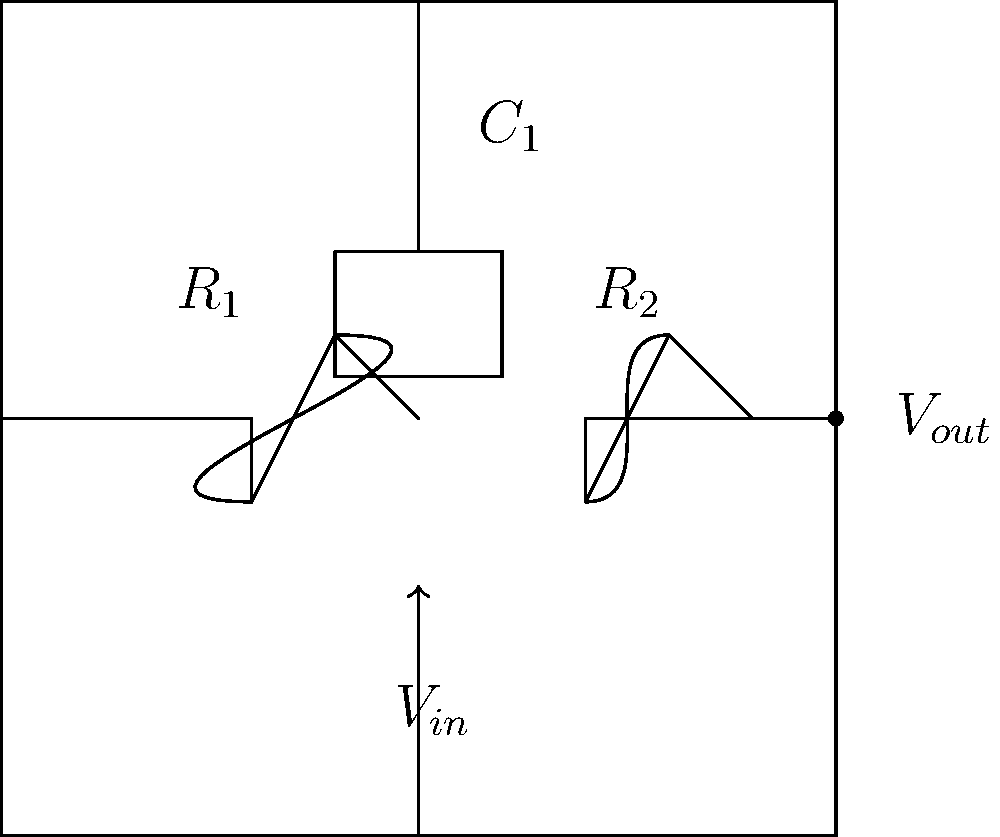In the given circuit schematic, which component determines the high-frequency response of the circuit, and how would increasing its value affect the circuit's behavior? To answer this question, let's analyze the circuit step-by-step:

1. The circuit shown is a basic RC low-pass filter.

2. It consists of two resistors ($R_1$ and $R_2$) and one capacitor ($C_1$).

3. In a low-pass filter, the capacitor is the key component that determines the high-frequency response.

4. The capacitor ($C_1$) is connected between the output node and ground.

5. At high frequencies, the capacitor's impedance decreases, effectively shunting high-frequency signals to ground.

6. The cutoff frequency of the filter is given by the formula:

   $f_c = \frac{1}{2\pi RC}$

   where $R$ is the equivalent resistance of $R_1$ and $R_2$ in parallel.

7. If we increase the value of $C_1$:
   - The cutoff frequency will decrease.
   - This means the circuit will start attenuating signals at a lower frequency.
   - The high-frequency response of the circuit will be reduced.

8. In the context of art and visual perception, this could be analogous to how increasing the softness of a brush or the amount of blurring in a digital filter would reduce the fine details (high-frequency components) in an image.

Therefore, the capacitor $C_1$ determines the high-frequency response, and increasing its value would lower the cutoff frequency, reducing the circuit's response to high-frequency signals.
Answer: $C_1$; increasing it would reduce high-frequency response 